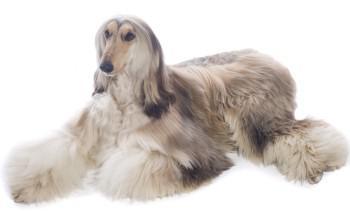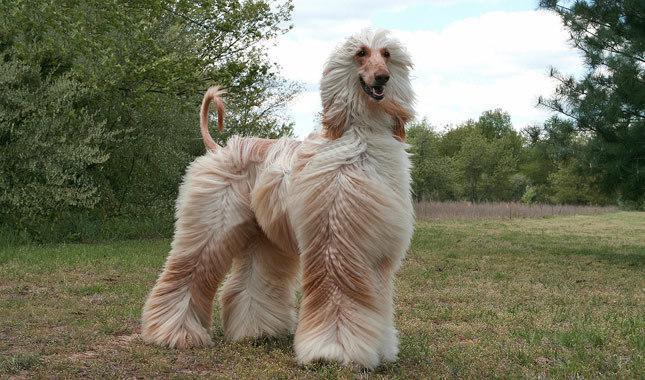The first image is the image on the left, the second image is the image on the right. Evaluate the accuracy of this statement regarding the images: "there is one dog lying down in the image on the left". Is it true? Answer yes or no. Yes. The first image is the image on the left, the second image is the image on the right. Examine the images to the left and right. Is the description "At least one dog has black fur." accurate? Answer yes or no. No. 